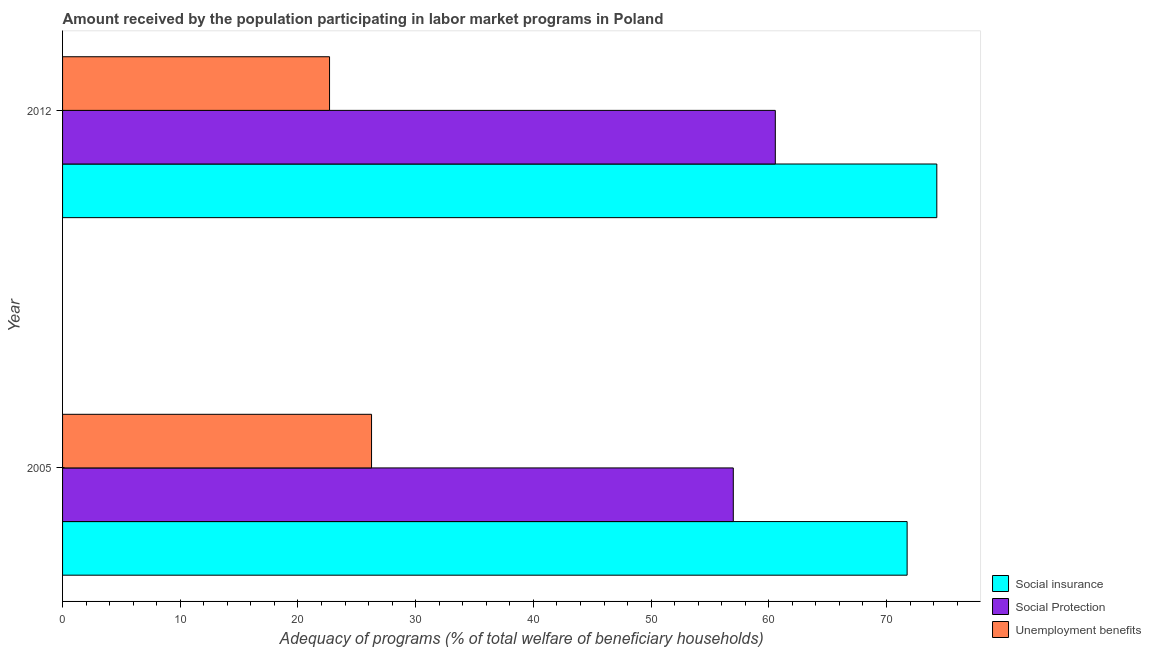Are the number of bars per tick equal to the number of legend labels?
Your answer should be compact. Yes. Are the number of bars on each tick of the Y-axis equal?
Offer a very short reply. Yes. How many bars are there on the 1st tick from the top?
Your response must be concise. 3. How many bars are there on the 1st tick from the bottom?
Make the answer very short. 3. What is the label of the 1st group of bars from the top?
Offer a terse response. 2012. What is the amount received by the population participating in unemployment benefits programs in 2012?
Your response must be concise. 22.68. Across all years, what is the maximum amount received by the population participating in social protection programs?
Offer a very short reply. 60.56. Across all years, what is the minimum amount received by the population participating in social insurance programs?
Offer a terse response. 71.75. In which year was the amount received by the population participating in social insurance programs minimum?
Give a very brief answer. 2005. What is the total amount received by the population participating in unemployment benefits programs in the graph?
Your answer should be compact. 48.93. What is the difference between the amount received by the population participating in social insurance programs in 2005 and that in 2012?
Your answer should be compact. -2.52. What is the difference between the amount received by the population participating in unemployment benefits programs in 2005 and the amount received by the population participating in social insurance programs in 2012?
Offer a very short reply. -48.03. What is the average amount received by the population participating in unemployment benefits programs per year?
Ensure brevity in your answer.  24.47. In the year 2012, what is the difference between the amount received by the population participating in social protection programs and amount received by the population participating in unemployment benefits programs?
Ensure brevity in your answer.  37.87. In how many years, is the amount received by the population participating in social insurance programs greater than the average amount received by the population participating in social insurance programs taken over all years?
Provide a short and direct response. 1. What does the 3rd bar from the top in 2012 represents?
Give a very brief answer. Social insurance. What does the 3rd bar from the bottom in 2012 represents?
Provide a short and direct response. Unemployment benefits. Is it the case that in every year, the sum of the amount received by the population participating in social insurance programs and amount received by the population participating in social protection programs is greater than the amount received by the population participating in unemployment benefits programs?
Offer a terse response. Yes. How many bars are there?
Your answer should be compact. 6. What is the difference between two consecutive major ticks on the X-axis?
Your answer should be very brief. 10. Are the values on the major ticks of X-axis written in scientific E-notation?
Your answer should be very brief. No. Does the graph contain any zero values?
Offer a terse response. No. Does the graph contain grids?
Ensure brevity in your answer.  No. Where does the legend appear in the graph?
Your answer should be very brief. Bottom right. How many legend labels are there?
Your answer should be compact. 3. How are the legend labels stacked?
Your answer should be very brief. Vertical. What is the title of the graph?
Provide a succinct answer. Amount received by the population participating in labor market programs in Poland. Does "Oil sources" appear as one of the legend labels in the graph?
Your answer should be compact. No. What is the label or title of the X-axis?
Offer a terse response. Adequacy of programs (% of total welfare of beneficiary households). What is the label or title of the Y-axis?
Your answer should be compact. Year. What is the Adequacy of programs (% of total welfare of beneficiary households) of Social insurance in 2005?
Give a very brief answer. 71.75. What is the Adequacy of programs (% of total welfare of beneficiary households) of Social Protection in 2005?
Provide a succinct answer. 56.99. What is the Adequacy of programs (% of total welfare of beneficiary households) of Unemployment benefits in 2005?
Provide a short and direct response. 26.25. What is the Adequacy of programs (% of total welfare of beneficiary households) of Social insurance in 2012?
Give a very brief answer. 74.28. What is the Adequacy of programs (% of total welfare of beneficiary households) of Social Protection in 2012?
Ensure brevity in your answer.  60.56. What is the Adequacy of programs (% of total welfare of beneficiary households) in Unemployment benefits in 2012?
Make the answer very short. 22.68. Across all years, what is the maximum Adequacy of programs (% of total welfare of beneficiary households) in Social insurance?
Ensure brevity in your answer.  74.28. Across all years, what is the maximum Adequacy of programs (% of total welfare of beneficiary households) of Social Protection?
Offer a very short reply. 60.56. Across all years, what is the maximum Adequacy of programs (% of total welfare of beneficiary households) in Unemployment benefits?
Keep it short and to the point. 26.25. Across all years, what is the minimum Adequacy of programs (% of total welfare of beneficiary households) in Social insurance?
Your response must be concise. 71.75. Across all years, what is the minimum Adequacy of programs (% of total welfare of beneficiary households) of Social Protection?
Your answer should be very brief. 56.99. Across all years, what is the minimum Adequacy of programs (% of total welfare of beneficiary households) in Unemployment benefits?
Keep it short and to the point. 22.68. What is the total Adequacy of programs (% of total welfare of beneficiary households) of Social insurance in the graph?
Keep it short and to the point. 146.03. What is the total Adequacy of programs (% of total welfare of beneficiary households) in Social Protection in the graph?
Provide a succinct answer. 117.54. What is the total Adequacy of programs (% of total welfare of beneficiary households) of Unemployment benefits in the graph?
Your response must be concise. 48.93. What is the difference between the Adequacy of programs (% of total welfare of beneficiary households) of Social insurance in 2005 and that in 2012?
Provide a succinct answer. -2.52. What is the difference between the Adequacy of programs (% of total welfare of beneficiary households) in Social Protection in 2005 and that in 2012?
Provide a short and direct response. -3.57. What is the difference between the Adequacy of programs (% of total welfare of beneficiary households) in Unemployment benefits in 2005 and that in 2012?
Keep it short and to the point. 3.57. What is the difference between the Adequacy of programs (% of total welfare of beneficiary households) in Social insurance in 2005 and the Adequacy of programs (% of total welfare of beneficiary households) in Social Protection in 2012?
Provide a succinct answer. 11.2. What is the difference between the Adequacy of programs (% of total welfare of beneficiary households) in Social insurance in 2005 and the Adequacy of programs (% of total welfare of beneficiary households) in Unemployment benefits in 2012?
Your answer should be compact. 49.07. What is the difference between the Adequacy of programs (% of total welfare of beneficiary households) of Social Protection in 2005 and the Adequacy of programs (% of total welfare of beneficiary households) of Unemployment benefits in 2012?
Give a very brief answer. 34.3. What is the average Adequacy of programs (% of total welfare of beneficiary households) in Social insurance per year?
Ensure brevity in your answer.  73.01. What is the average Adequacy of programs (% of total welfare of beneficiary households) of Social Protection per year?
Offer a very short reply. 58.77. What is the average Adequacy of programs (% of total welfare of beneficiary households) of Unemployment benefits per year?
Give a very brief answer. 24.47. In the year 2005, what is the difference between the Adequacy of programs (% of total welfare of beneficiary households) in Social insurance and Adequacy of programs (% of total welfare of beneficiary households) in Social Protection?
Keep it short and to the point. 14.77. In the year 2005, what is the difference between the Adequacy of programs (% of total welfare of beneficiary households) in Social insurance and Adequacy of programs (% of total welfare of beneficiary households) in Unemployment benefits?
Your answer should be compact. 45.5. In the year 2005, what is the difference between the Adequacy of programs (% of total welfare of beneficiary households) in Social Protection and Adequacy of programs (% of total welfare of beneficiary households) in Unemployment benefits?
Your answer should be very brief. 30.74. In the year 2012, what is the difference between the Adequacy of programs (% of total welfare of beneficiary households) of Social insurance and Adequacy of programs (% of total welfare of beneficiary households) of Social Protection?
Keep it short and to the point. 13.72. In the year 2012, what is the difference between the Adequacy of programs (% of total welfare of beneficiary households) of Social insurance and Adequacy of programs (% of total welfare of beneficiary households) of Unemployment benefits?
Your answer should be very brief. 51.59. In the year 2012, what is the difference between the Adequacy of programs (% of total welfare of beneficiary households) in Social Protection and Adequacy of programs (% of total welfare of beneficiary households) in Unemployment benefits?
Your answer should be very brief. 37.87. What is the ratio of the Adequacy of programs (% of total welfare of beneficiary households) in Social insurance in 2005 to that in 2012?
Offer a terse response. 0.97. What is the ratio of the Adequacy of programs (% of total welfare of beneficiary households) in Social Protection in 2005 to that in 2012?
Ensure brevity in your answer.  0.94. What is the ratio of the Adequacy of programs (% of total welfare of beneficiary households) in Unemployment benefits in 2005 to that in 2012?
Your answer should be compact. 1.16. What is the difference between the highest and the second highest Adequacy of programs (% of total welfare of beneficiary households) of Social insurance?
Make the answer very short. 2.52. What is the difference between the highest and the second highest Adequacy of programs (% of total welfare of beneficiary households) of Social Protection?
Keep it short and to the point. 3.57. What is the difference between the highest and the second highest Adequacy of programs (% of total welfare of beneficiary households) in Unemployment benefits?
Your answer should be very brief. 3.57. What is the difference between the highest and the lowest Adequacy of programs (% of total welfare of beneficiary households) in Social insurance?
Keep it short and to the point. 2.52. What is the difference between the highest and the lowest Adequacy of programs (% of total welfare of beneficiary households) of Social Protection?
Make the answer very short. 3.57. What is the difference between the highest and the lowest Adequacy of programs (% of total welfare of beneficiary households) in Unemployment benefits?
Offer a terse response. 3.57. 